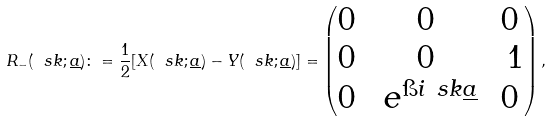Convert formula to latex. <formula><loc_0><loc_0><loc_500><loc_500>R _ { - } ( \ s k ; \underline { a } ) \colon = \frac { 1 } { 2 } [ X ( \ s k ; \underline { a } ) - Y ( \ s k ; \underline { a } ) ] = \begin{pmatrix} 0 & 0 & 0 \\ 0 & 0 & \ 1 \\ 0 & \ e ^ { \i i \ s k \underline { a } } & 0 \end{pmatrix} ,</formula> 